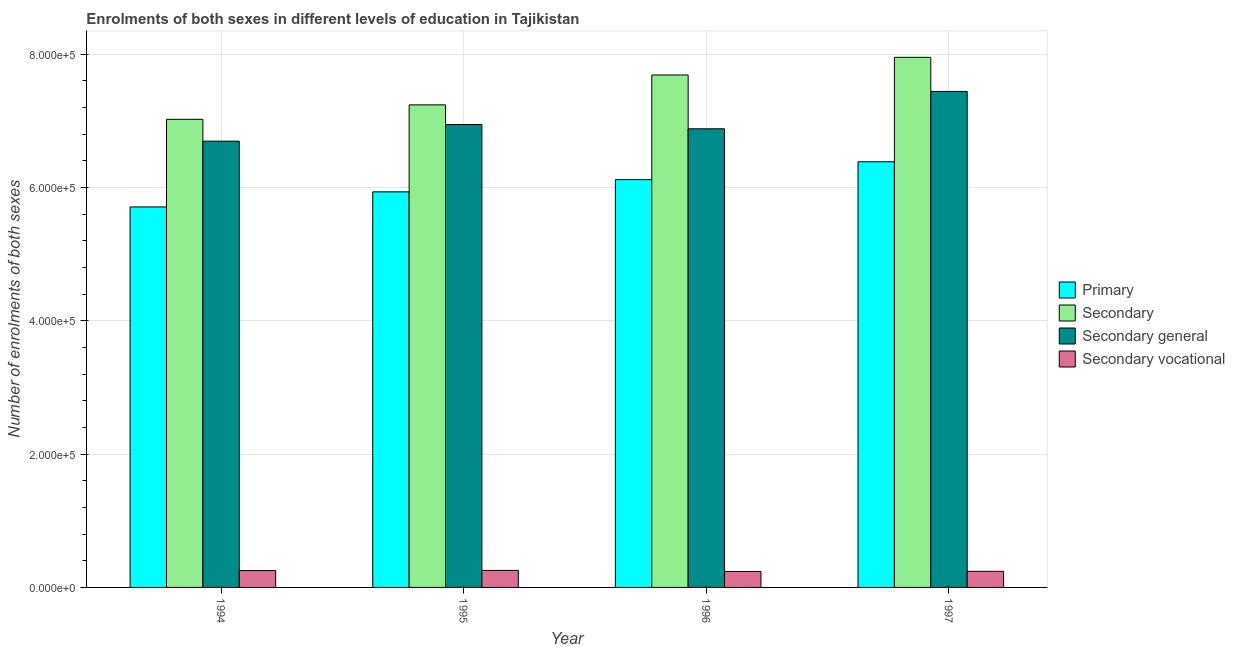How many different coloured bars are there?
Give a very brief answer. 4. How many groups of bars are there?
Your answer should be very brief. 4. Are the number of bars on each tick of the X-axis equal?
Ensure brevity in your answer.  Yes. How many bars are there on the 1st tick from the right?
Provide a short and direct response. 4. What is the label of the 2nd group of bars from the left?
Give a very brief answer. 1995. In how many cases, is the number of bars for a given year not equal to the number of legend labels?
Your response must be concise. 0. What is the number of enrolments in secondary vocational education in 1997?
Keep it short and to the point. 2.42e+04. Across all years, what is the maximum number of enrolments in secondary general education?
Make the answer very short. 7.44e+05. Across all years, what is the minimum number of enrolments in secondary vocational education?
Offer a very short reply. 2.39e+04. In which year was the number of enrolments in secondary vocational education maximum?
Offer a terse response. 1995. In which year was the number of enrolments in secondary general education minimum?
Give a very brief answer. 1994. What is the total number of enrolments in secondary vocational education in the graph?
Give a very brief answer. 9.90e+04. What is the difference between the number of enrolments in primary education in 1995 and that in 1997?
Your response must be concise. -4.51e+04. What is the difference between the number of enrolments in secondary general education in 1995 and the number of enrolments in primary education in 1996?
Give a very brief answer. 6424. What is the average number of enrolments in secondary education per year?
Offer a very short reply. 7.48e+05. In the year 1997, what is the difference between the number of enrolments in primary education and number of enrolments in secondary education?
Ensure brevity in your answer.  0. What is the ratio of the number of enrolments in secondary general education in 1996 to that in 1997?
Your answer should be compact. 0.92. Is the number of enrolments in secondary vocational education in 1994 less than that in 1996?
Keep it short and to the point. No. What is the difference between the highest and the second highest number of enrolments in primary education?
Give a very brief answer. 2.68e+04. What is the difference between the highest and the lowest number of enrolments in secondary vocational education?
Keep it short and to the point. 1635. In how many years, is the number of enrolments in secondary education greater than the average number of enrolments in secondary education taken over all years?
Offer a terse response. 2. Is the sum of the number of enrolments in primary education in 1994 and 1997 greater than the maximum number of enrolments in secondary vocational education across all years?
Keep it short and to the point. Yes. What does the 3rd bar from the left in 1996 represents?
Give a very brief answer. Secondary general. What does the 4th bar from the right in 1997 represents?
Provide a short and direct response. Primary. Is it the case that in every year, the sum of the number of enrolments in primary education and number of enrolments in secondary education is greater than the number of enrolments in secondary general education?
Your answer should be very brief. Yes. How many bars are there?
Your answer should be very brief. 16. Are all the bars in the graph horizontal?
Your response must be concise. No. How many years are there in the graph?
Offer a terse response. 4. What is the difference between two consecutive major ticks on the Y-axis?
Keep it short and to the point. 2.00e+05. Does the graph contain any zero values?
Your response must be concise. No. How many legend labels are there?
Provide a short and direct response. 4. What is the title of the graph?
Keep it short and to the point. Enrolments of both sexes in different levels of education in Tajikistan. What is the label or title of the Y-axis?
Your answer should be very brief. Number of enrolments of both sexes. What is the Number of enrolments of both sexes of Primary in 1994?
Keep it short and to the point. 5.71e+05. What is the Number of enrolments of both sexes in Secondary in 1994?
Your response must be concise. 7.02e+05. What is the Number of enrolments of both sexes in Secondary general in 1994?
Offer a very short reply. 6.70e+05. What is the Number of enrolments of both sexes in Secondary vocational in 1994?
Your response must be concise. 2.53e+04. What is the Number of enrolments of both sexes of Primary in 1995?
Your answer should be compact. 5.94e+05. What is the Number of enrolments of both sexes of Secondary in 1995?
Provide a succinct answer. 7.24e+05. What is the Number of enrolments of both sexes in Secondary general in 1995?
Keep it short and to the point. 6.95e+05. What is the Number of enrolments of both sexes in Secondary vocational in 1995?
Keep it short and to the point. 2.55e+04. What is the Number of enrolments of both sexes of Primary in 1996?
Your response must be concise. 6.12e+05. What is the Number of enrolments of both sexes in Secondary in 1996?
Provide a succinct answer. 7.69e+05. What is the Number of enrolments of both sexes of Secondary general in 1996?
Give a very brief answer. 6.88e+05. What is the Number of enrolments of both sexes in Secondary vocational in 1996?
Your answer should be compact. 2.39e+04. What is the Number of enrolments of both sexes of Primary in 1997?
Provide a succinct answer. 6.39e+05. What is the Number of enrolments of both sexes in Secondary in 1997?
Make the answer very short. 7.95e+05. What is the Number of enrolments of both sexes in Secondary general in 1997?
Ensure brevity in your answer.  7.44e+05. What is the Number of enrolments of both sexes in Secondary vocational in 1997?
Your answer should be very brief. 2.42e+04. Across all years, what is the maximum Number of enrolments of both sexes of Primary?
Provide a short and direct response. 6.39e+05. Across all years, what is the maximum Number of enrolments of both sexes of Secondary?
Keep it short and to the point. 7.95e+05. Across all years, what is the maximum Number of enrolments of both sexes in Secondary general?
Offer a terse response. 7.44e+05. Across all years, what is the maximum Number of enrolments of both sexes of Secondary vocational?
Your answer should be very brief. 2.55e+04. Across all years, what is the minimum Number of enrolments of both sexes of Primary?
Give a very brief answer. 5.71e+05. Across all years, what is the minimum Number of enrolments of both sexes in Secondary?
Provide a short and direct response. 7.02e+05. Across all years, what is the minimum Number of enrolments of both sexes of Secondary general?
Give a very brief answer. 6.70e+05. Across all years, what is the minimum Number of enrolments of both sexes of Secondary vocational?
Keep it short and to the point. 2.39e+04. What is the total Number of enrolments of both sexes of Primary in the graph?
Give a very brief answer. 2.42e+06. What is the total Number of enrolments of both sexes of Secondary in the graph?
Make the answer very short. 2.99e+06. What is the total Number of enrolments of both sexes of Secondary general in the graph?
Ensure brevity in your answer.  2.80e+06. What is the total Number of enrolments of both sexes in Secondary vocational in the graph?
Ensure brevity in your answer.  9.90e+04. What is the difference between the Number of enrolments of both sexes of Primary in 1994 and that in 1995?
Your answer should be compact. -2.26e+04. What is the difference between the Number of enrolments of both sexes of Secondary in 1994 and that in 1995?
Offer a very short reply. -2.17e+04. What is the difference between the Number of enrolments of both sexes in Secondary general in 1994 and that in 1995?
Offer a terse response. -2.50e+04. What is the difference between the Number of enrolments of both sexes of Secondary vocational in 1994 and that in 1995?
Give a very brief answer. -223. What is the difference between the Number of enrolments of both sexes of Primary in 1994 and that in 1996?
Offer a very short reply. -4.10e+04. What is the difference between the Number of enrolments of both sexes of Secondary in 1994 and that in 1996?
Offer a very short reply. -6.65e+04. What is the difference between the Number of enrolments of both sexes in Secondary general in 1994 and that in 1996?
Keep it short and to the point. -1.86e+04. What is the difference between the Number of enrolments of both sexes of Secondary vocational in 1994 and that in 1996?
Your answer should be very brief. 1412. What is the difference between the Number of enrolments of both sexes of Primary in 1994 and that in 1997?
Ensure brevity in your answer.  -6.78e+04. What is the difference between the Number of enrolments of both sexes in Secondary in 1994 and that in 1997?
Provide a succinct answer. -9.30e+04. What is the difference between the Number of enrolments of both sexes in Secondary general in 1994 and that in 1997?
Your response must be concise. -7.46e+04. What is the difference between the Number of enrolments of both sexes of Secondary vocational in 1994 and that in 1997?
Make the answer very short. 1128. What is the difference between the Number of enrolments of both sexes in Primary in 1995 and that in 1996?
Your answer should be very brief. -1.84e+04. What is the difference between the Number of enrolments of both sexes of Secondary in 1995 and that in 1996?
Keep it short and to the point. -4.48e+04. What is the difference between the Number of enrolments of both sexes in Secondary general in 1995 and that in 1996?
Give a very brief answer. 6424. What is the difference between the Number of enrolments of both sexes of Secondary vocational in 1995 and that in 1996?
Your answer should be very brief. 1635. What is the difference between the Number of enrolments of both sexes of Primary in 1995 and that in 1997?
Provide a short and direct response. -4.51e+04. What is the difference between the Number of enrolments of both sexes in Secondary in 1995 and that in 1997?
Make the answer very short. -7.13e+04. What is the difference between the Number of enrolments of both sexes of Secondary general in 1995 and that in 1997?
Provide a short and direct response. -4.96e+04. What is the difference between the Number of enrolments of both sexes in Secondary vocational in 1995 and that in 1997?
Keep it short and to the point. 1351. What is the difference between the Number of enrolments of both sexes in Primary in 1996 and that in 1997?
Give a very brief answer. -2.68e+04. What is the difference between the Number of enrolments of both sexes in Secondary in 1996 and that in 1997?
Keep it short and to the point. -2.65e+04. What is the difference between the Number of enrolments of both sexes in Secondary general in 1996 and that in 1997?
Your response must be concise. -5.61e+04. What is the difference between the Number of enrolments of both sexes of Secondary vocational in 1996 and that in 1997?
Make the answer very short. -284. What is the difference between the Number of enrolments of both sexes of Primary in 1994 and the Number of enrolments of both sexes of Secondary in 1995?
Make the answer very short. -1.53e+05. What is the difference between the Number of enrolments of both sexes of Primary in 1994 and the Number of enrolments of both sexes of Secondary general in 1995?
Offer a terse response. -1.24e+05. What is the difference between the Number of enrolments of both sexes of Primary in 1994 and the Number of enrolments of both sexes of Secondary vocational in 1995?
Your response must be concise. 5.45e+05. What is the difference between the Number of enrolments of both sexes in Secondary in 1994 and the Number of enrolments of both sexes in Secondary general in 1995?
Provide a succinct answer. 7801. What is the difference between the Number of enrolments of both sexes in Secondary in 1994 and the Number of enrolments of both sexes in Secondary vocational in 1995?
Give a very brief answer. 6.77e+05. What is the difference between the Number of enrolments of both sexes in Secondary general in 1994 and the Number of enrolments of both sexes in Secondary vocational in 1995?
Keep it short and to the point. 6.44e+05. What is the difference between the Number of enrolments of both sexes of Primary in 1994 and the Number of enrolments of both sexes of Secondary in 1996?
Ensure brevity in your answer.  -1.98e+05. What is the difference between the Number of enrolments of both sexes in Primary in 1994 and the Number of enrolments of both sexes in Secondary general in 1996?
Your response must be concise. -1.17e+05. What is the difference between the Number of enrolments of both sexes in Primary in 1994 and the Number of enrolments of both sexes in Secondary vocational in 1996?
Offer a terse response. 5.47e+05. What is the difference between the Number of enrolments of both sexes of Secondary in 1994 and the Number of enrolments of both sexes of Secondary general in 1996?
Your answer should be very brief. 1.42e+04. What is the difference between the Number of enrolments of both sexes in Secondary in 1994 and the Number of enrolments of both sexes in Secondary vocational in 1996?
Make the answer very short. 6.78e+05. What is the difference between the Number of enrolments of both sexes in Secondary general in 1994 and the Number of enrolments of both sexes in Secondary vocational in 1996?
Keep it short and to the point. 6.46e+05. What is the difference between the Number of enrolments of both sexes in Primary in 1994 and the Number of enrolments of both sexes in Secondary in 1997?
Your answer should be very brief. -2.24e+05. What is the difference between the Number of enrolments of both sexes of Primary in 1994 and the Number of enrolments of both sexes of Secondary general in 1997?
Provide a short and direct response. -1.73e+05. What is the difference between the Number of enrolments of both sexes of Primary in 1994 and the Number of enrolments of both sexes of Secondary vocational in 1997?
Keep it short and to the point. 5.47e+05. What is the difference between the Number of enrolments of both sexes in Secondary in 1994 and the Number of enrolments of both sexes in Secondary general in 1997?
Keep it short and to the point. -4.18e+04. What is the difference between the Number of enrolments of both sexes of Secondary in 1994 and the Number of enrolments of both sexes of Secondary vocational in 1997?
Offer a terse response. 6.78e+05. What is the difference between the Number of enrolments of both sexes in Secondary general in 1994 and the Number of enrolments of both sexes in Secondary vocational in 1997?
Make the answer very short. 6.45e+05. What is the difference between the Number of enrolments of both sexes in Primary in 1995 and the Number of enrolments of both sexes in Secondary in 1996?
Your answer should be compact. -1.75e+05. What is the difference between the Number of enrolments of both sexes in Primary in 1995 and the Number of enrolments of both sexes in Secondary general in 1996?
Make the answer very short. -9.46e+04. What is the difference between the Number of enrolments of both sexes in Primary in 1995 and the Number of enrolments of both sexes in Secondary vocational in 1996?
Your response must be concise. 5.70e+05. What is the difference between the Number of enrolments of both sexes in Secondary in 1995 and the Number of enrolments of both sexes in Secondary general in 1996?
Provide a short and direct response. 3.59e+04. What is the difference between the Number of enrolments of both sexes in Secondary in 1995 and the Number of enrolments of both sexes in Secondary vocational in 1996?
Your response must be concise. 7.00e+05. What is the difference between the Number of enrolments of both sexes of Secondary general in 1995 and the Number of enrolments of both sexes of Secondary vocational in 1996?
Give a very brief answer. 6.71e+05. What is the difference between the Number of enrolments of both sexes of Primary in 1995 and the Number of enrolments of both sexes of Secondary in 1997?
Offer a very short reply. -2.02e+05. What is the difference between the Number of enrolments of both sexes in Primary in 1995 and the Number of enrolments of both sexes in Secondary general in 1997?
Make the answer very short. -1.51e+05. What is the difference between the Number of enrolments of both sexes of Primary in 1995 and the Number of enrolments of both sexes of Secondary vocational in 1997?
Provide a succinct answer. 5.69e+05. What is the difference between the Number of enrolments of both sexes of Secondary in 1995 and the Number of enrolments of both sexes of Secondary general in 1997?
Offer a very short reply. -2.02e+04. What is the difference between the Number of enrolments of both sexes of Secondary in 1995 and the Number of enrolments of both sexes of Secondary vocational in 1997?
Make the answer very short. 7.00e+05. What is the difference between the Number of enrolments of both sexes of Secondary general in 1995 and the Number of enrolments of both sexes of Secondary vocational in 1997?
Offer a very short reply. 6.70e+05. What is the difference between the Number of enrolments of both sexes of Primary in 1996 and the Number of enrolments of both sexes of Secondary in 1997?
Provide a short and direct response. -1.83e+05. What is the difference between the Number of enrolments of both sexes in Primary in 1996 and the Number of enrolments of both sexes in Secondary general in 1997?
Ensure brevity in your answer.  -1.32e+05. What is the difference between the Number of enrolments of both sexes of Primary in 1996 and the Number of enrolments of both sexes of Secondary vocational in 1997?
Ensure brevity in your answer.  5.88e+05. What is the difference between the Number of enrolments of both sexes in Secondary in 1996 and the Number of enrolments of both sexes in Secondary general in 1997?
Your answer should be compact. 2.47e+04. What is the difference between the Number of enrolments of both sexes in Secondary in 1996 and the Number of enrolments of both sexes in Secondary vocational in 1997?
Keep it short and to the point. 7.45e+05. What is the difference between the Number of enrolments of both sexes in Secondary general in 1996 and the Number of enrolments of both sexes in Secondary vocational in 1997?
Offer a very short reply. 6.64e+05. What is the average Number of enrolments of both sexes of Primary per year?
Make the answer very short. 6.04e+05. What is the average Number of enrolments of both sexes in Secondary per year?
Your answer should be very brief. 7.48e+05. What is the average Number of enrolments of both sexes of Secondary general per year?
Provide a short and direct response. 6.99e+05. What is the average Number of enrolments of both sexes in Secondary vocational per year?
Offer a terse response. 2.47e+04. In the year 1994, what is the difference between the Number of enrolments of both sexes of Primary and Number of enrolments of both sexes of Secondary?
Offer a terse response. -1.31e+05. In the year 1994, what is the difference between the Number of enrolments of both sexes in Primary and Number of enrolments of both sexes in Secondary general?
Give a very brief answer. -9.87e+04. In the year 1994, what is the difference between the Number of enrolments of both sexes of Primary and Number of enrolments of both sexes of Secondary vocational?
Provide a succinct answer. 5.46e+05. In the year 1994, what is the difference between the Number of enrolments of both sexes in Secondary and Number of enrolments of both sexes in Secondary general?
Provide a short and direct response. 3.28e+04. In the year 1994, what is the difference between the Number of enrolments of both sexes of Secondary and Number of enrolments of both sexes of Secondary vocational?
Your answer should be very brief. 6.77e+05. In the year 1994, what is the difference between the Number of enrolments of both sexes of Secondary general and Number of enrolments of both sexes of Secondary vocational?
Ensure brevity in your answer.  6.44e+05. In the year 1995, what is the difference between the Number of enrolments of both sexes in Primary and Number of enrolments of both sexes in Secondary?
Provide a short and direct response. -1.31e+05. In the year 1995, what is the difference between the Number of enrolments of both sexes in Primary and Number of enrolments of both sexes in Secondary general?
Offer a very short reply. -1.01e+05. In the year 1995, what is the difference between the Number of enrolments of both sexes of Primary and Number of enrolments of both sexes of Secondary vocational?
Make the answer very short. 5.68e+05. In the year 1995, what is the difference between the Number of enrolments of both sexes of Secondary and Number of enrolments of both sexes of Secondary general?
Your answer should be compact. 2.95e+04. In the year 1995, what is the difference between the Number of enrolments of both sexes in Secondary and Number of enrolments of both sexes in Secondary vocational?
Give a very brief answer. 6.99e+05. In the year 1995, what is the difference between the Number of enrolments of both sexes in Secondary general and Number of enrolments of both sexes in Secondary vocational?
Your answer should be very brief. 6.69e+05. In the year 1996, what is the difference between the Number of enrolments of both sexes of Primary and Number of enrolments of both sexes of Secondary?
Make the answer very short. -1.57e+05. In the year 1996, what is the difference between the Number of enrolments of both sexes in Primary and Number of enrolments of both sexes in Secondary general?
Make the answer very short. -7.62e+04. In the year 1996, what is the difference between the Number of enrolments of both sexes in Primary and Number of enrolments of both sexes in Secondary vocational?
Provide a succinct answer. 5.88e+05. In the year 1996, what is the difference between the Number of enrolments of both sexes in Secondary and Number of enrolments of both sexes in Secondary general?
Keep it short and to the point. 8.08e+04. In the year 1996, what is the difference between the Number of enrolments of both sexes in Secondary and Number of enrolments of both sexes in Secondary vocational?
Offer a very short reply. 7.45e+05. In the year 1996, what is the difference between the Number of enrolments of both sexes of Secondary general and Number of enrolments of both sexes of Secondary vocational?
Keep it short and to the point. 6.64e+05. In the year 1997, what is the difference between the Number of enrolments of both sexes in Primary and Number of enrolments of both sexes in Secondary?
Make the answer very short. -1.57e+05. In the year 1997, what is the difference between the Number of enrolments of both sexes of Primary and Number of enrolments of both sexes of Secondary general?
Provide a short and direct response. -1.06e+05. In the year 1997, what is the difference between the Number of enrolments of both sexes of Primary and Number of enrolments of both sexes of Secondary vocational?
Give a very brief answer. 6.14e+05. In the year 1997, what is the difference between the Number of enrolments of both sexes in Secondary and Number of enrolments of both sexes in Secondary general?
Offer a very short reply. 5.12e+04. In the year 1997, what is the difference between the Number of enrolments of both sexes of Secondary and Number of enrolments of both sexes of Secondary vocational?
Your answer should be very brief. 7.71e+05. In the year 1997, what is the difference between the Number of enrolments of both sexes of Secondary general and Number of enrolments of both sexes of Secondary vocational?
Offer a terse response. 7.20e+05. What is the ratio of the Number of enrolments of both sexes of Primary in 1994 to that in 1995?
Your answer should be very brief. 0.96. What is the ratio of the Number of enrolments of both sexes of Secondary in 1994 to that in 1995?
Provide a short and direct response. 0.97. What is the ratio of the Number of enrolments of both sexes in Secondary general in 1994 to that in 1995?
Ensure brevity in your answer.  0.96. What is the ratio of the Number of enrolments of both sexes of Primary in 1994 to that in 1996?
Ensure brevity in your answer.  0.93. What is the ratio of the Number of enrolments of both sexes in Secondary in 1994 to that in 1996?
Keep it short and to the point. 0.91. What is the ratio of the Number of enrolments of both sexes of Secondary vocational in 1994 to that in 1996?
Provide a succinct answer. 1.06. What is the ratio of the Number of enrolments of both sexes in Primary in 1994 to that in 1997?
Offer a terse response. 0.89. What is the ratio of the Number of enrolments of both sexes in Secondary in 1994 to that in 1997?
Give a very brief answer. 0.88. What is the ratio of the Number of enrolments of both sexes of Secondary general in 1994 to that in 1997?
Your answer should be very brief. 0.9. What is the ratio of the Number of enrolments of both sexes in Secondary vocational in 1994 to that in 1997?
Give a very brief answer. 1.05. What is the ratio of the Number of enrolments of both sexes in Secondary in 1995 to that in 1996?
Offer a terse response. 0.94. What is the ratio of the Number of enrolments of both sexes in Secondary general in 1995 to that in 1996?
Provide a succinct answer. 1.01. What is the ratio of the Number of enrolments of both sexes in Secondary vocational in 1995 to that in 1996?
Give a very brief answer. 1.07. What is the ratio of the Number of enrolments of both sexes in Primary in 1995 to that in 1997?
Ensure brevity in your answer.  0.93. What is the ratio of the Number of enrolments of both sexes of Secondary in 1995 to that in 1997?
Offer a very short reply. 0.91. What is the ratio of the Number of enrolments of both sexes in Secondary vocational in 1995 to that in 1997?
Provide a succinct answer. 1.06. What is the ratio of the Number of enrolments of both sexes in Primary in 1996 to that in 1997?
Your response must be concise. 0.96. What is the ratio of the Number of enrolments of both sexes of Secondary in 1996 to that in 1997?
Keep it short and to the point. 0.97. What is the ratio of the Number of enrolments of both sexes of Secondary general in 1996 to that in 1997?
Keep it short and to the point. 0.92. What is the ratio of the Number of enrolments of both sexes of Secondary vocational in 1996 to that in 1997?
Ensure brevity in your answer.  0.99. What is the difference between the highest and the second highest Number of enrolments of both sexes in Primary?
Your answer should be very brief. 2.68e+04. What is the difference between the highest and the second highest Number of enrolments of both sexes of Secondary?
Your answer should be compact. 2.65e+04. What is the difference between the highest and the second highest Number of enrolments of both sexes of Secondary general?
Keep it short and to the point. 4.96e+04. What is the difference between the highest and the second highest Number of enrolments of both sexes in Secondary vocational?
Keep it short and to the point. 223. What is the difference between the highest and the lowest Number of enrolments of both sexes of Primary?
Your response must be concise. 6.78e+04. What is the difference between the highest and the lowest Number of enrolments of both sexes of Secondary?
Offer a very short reply. 9.30e+04. What is the difference between the highest and the lowest Number of enrolments of both sexes of Secondary general?
Make the answer very short. 7.46e+04. What is the difference between the highest and the lowest Number of enrolments of both sexes in Secondary vocational?
Ensure brevity in your answer.  1635. 